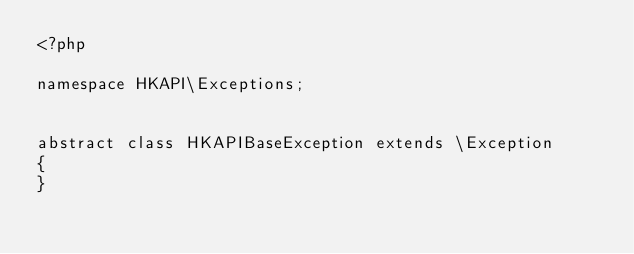Convert code to text. <code><loc_0><loc_0><loc_500><loc_500><_PHP_><?php

namespace HKAPI\Exceptions;


abstract class HKAPIBaseException extends \Exception
{
}</code> 